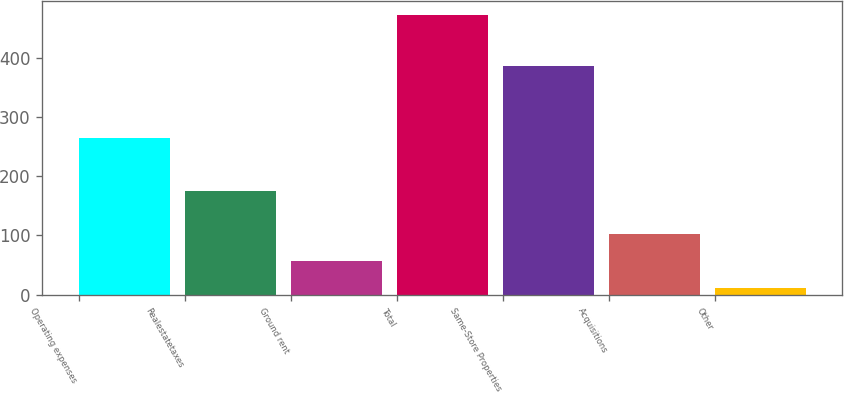Convert chart to OTSL. <chart><loc_0><loc_0><loc_500><loc_500><bar_chart><fcel>Operating expenses<fcel>Realestatetaxes<fcel>Ground rent<fcel>Total<fcel>Same-Store Properties<fcel>Acquisitions<fcel>Other<nl><fcel>263.7<fcel>174.5<fcel>57.19<fcel>471.1<fcel>385.9<fcel>103.18<fcel>11.2<nl></chart> 